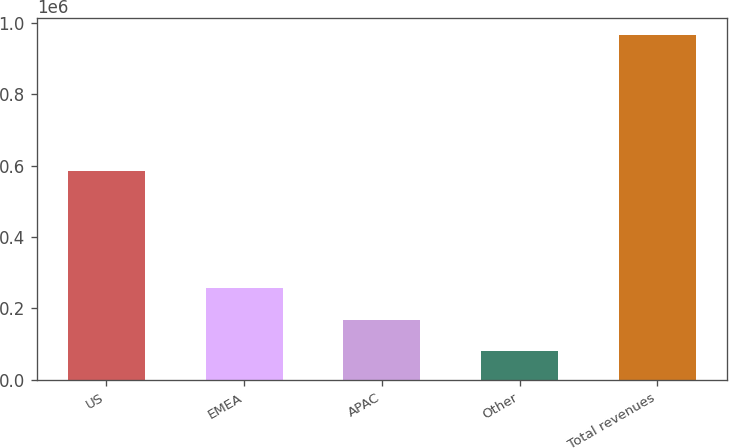Convert chart to OTSL. <chart><loc_0><loc_0><loc_500><loc_500><bar_chart><fcel>US<fcel>EMEA<fcel>APAC<fcel>Other<fcel>Total revenues<nl><fcel>585201<fcel>257381<fcel>168918<fcel>80455<fcel>965087<nl></chart> 